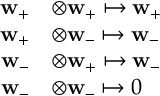Convert formula to latex. <formula><loc_0><loc_0><loc_500><loc_500>\begin{array} { r l } { w _ { + } } & { \otimes w _ { + } \mapsto w _ { + } } \\ { w _ { + } } & { \otimes w _ { - } \mapsto w _ { - } } \\ { w _ { - } } & { \otimes w _ { + } \mapsto w _ { - } } \\ { w _ { - } } & { \otimes w _ { - } \mapsto 0 } \end{array}</formula> 